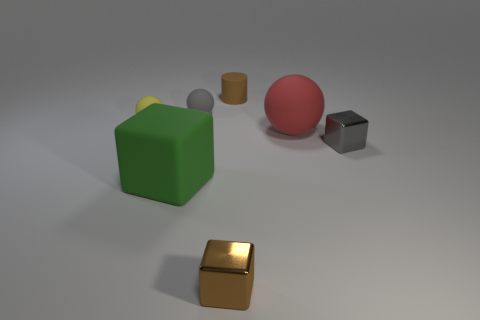Add 2 large green metallic balls. How many objects exist? 9 Subtract all spheres. How many objects are left? 4 Subtract 1 brown cubes. How many objects are left? 6 Subtract all big green rubber things. Subtract all big red things. How many objects are left? 5 Add 6 tiny gray shiny blocks. How many tiny gray shiny blocks are left? 7 Add 6 purple metal balls. How many purple metal balls exist? 6 